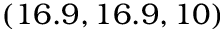<formula> <loc_0><loc_0><loc_500><loc_500>( 1 6 . 9 , 1 6 . 9 , 1 0 )</formula> 